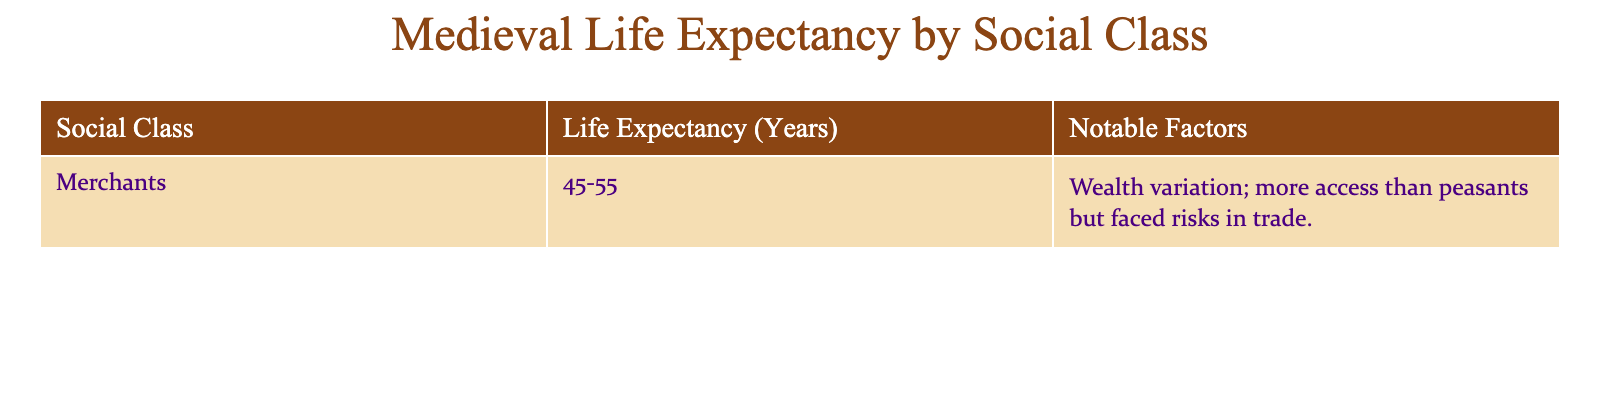What is the life expectancy range for merchants? The table shows the life expectancy for merchants is listed as 45-55 years. This information is directly retrieved from the "Life Expectancy (Years)" column corresponding to the "Merchants" row.
Answer: 45-55 What notable factors are associated with the life expectancy of merchants? The table mentions that merchants experience wealth variation and have more access to resources than peasants, but they also face risks in trade. This is found in the "Notable Factors" column for the merchants' row.
Answer: Wealth variation; more access but face risks in trade Are merchants likely to have a higher life expectancy than peasants? The table does not provide information on peasants, so it cannot be determined if merchants have a higher life expectancy than peasants based solely on the data present.
Answer: Cannot determine What is the average life expectancy range for merchants? The range given for merchants is 45-55 years. To find the average, we take the sum of the lower and upper bounds (45 + 55 = 100), then divide by 2 to find the mean (100 / 2 = 50). Thus, the average life expectancy for merchants is 50 years.
Answer: 50 Is it true that all social classes have the same life expectancy? The table only includes information for merchants and does not provide data for other social classes, so it cannot be concluded that all classes share the same life expectancy.
Answer: No, it's not true Which social class has the least detailed information in the table? The table provides detailed information only for the merchants. There are no other classes listed in the provided data, making it evident that merchants have the least detailed information as they are the only social class mentioned.
Answer: Merchants What can impact the life expectancy of merchants? According to the table, wealth variation, access to resources, and risks in trade are notable factors influencing the life expectancy of merchants, illustrating how social and economic factors play a role.
Answer: Wealth variation; access; risks in trade If the life expectancy of merchants is at its maximum, what year do they reach? The maximum life expectancy for merchants is 55 years. Assuming the average Medieval lifespan is calculated from the age of adulthood (around 20), one can deduce that if they live to 55, it suggests they reach that age around 55 years old, indicating a lifespan fluctuation. This interpretation can vary based on numerous factors not fully considered in the table.
Answer: 55 years old 